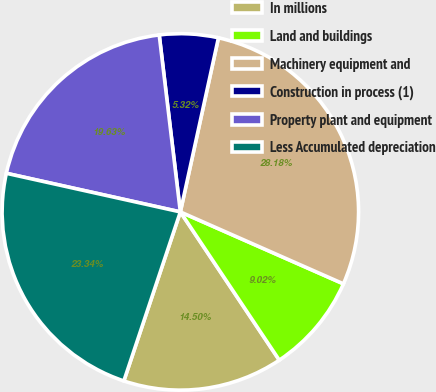<chart> <loc_0><loc_0><loc_500><loc_500><pie_chart><fcel>In millions<fcel>Land and buildings<fcel>Machinery equipment and<fcel>Construction in process (1)<fcel>Property plant and equipment<fcel>Less Accumulated depreciation<nl><fcel>14.5%<fcel>9.02%<fcel>28.18%<fcel>5.32%<fcel>19.63%<fcel>23.34%<nl></chart> 